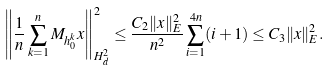<formula> <loc_0><loc_0><loc_500><loc_500>\left \| \frac { 1 } { n } \sum _ { k = 1 } ^ { n } M _ { h _ { 0 } ^ { k } } x \right \| _ { H ^ { 2 } _ { d } } ^ { 2 } & \leq \frac { C _ { 2 } \| x \| _ { E } ^ { 2 } } { n ^ { 2 } } \sum _ { i = 1 } ^ { 4 n } ( i + 1 ) \leq C _ { 3 } \| x \| _ { E } ^ { 2 } .</formula> 